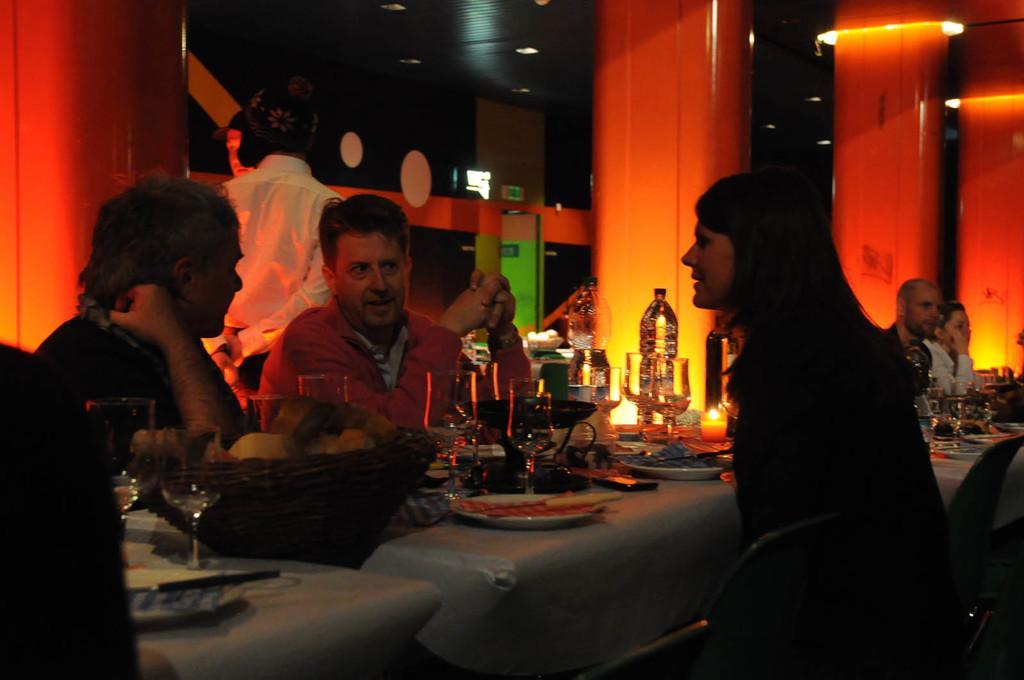Describe this image in one or two sentences. In this image there are three persons who are sitting on chairs, and in the background there are two persons who are sitting. In the center there is one table, on the table we could see some baskets, glasses, bottles, plates, knives, food items, spoons, forks, and in the background there is one man who is standing and also we could see some pillars. On the top of the image there is ceiling and some lights. 